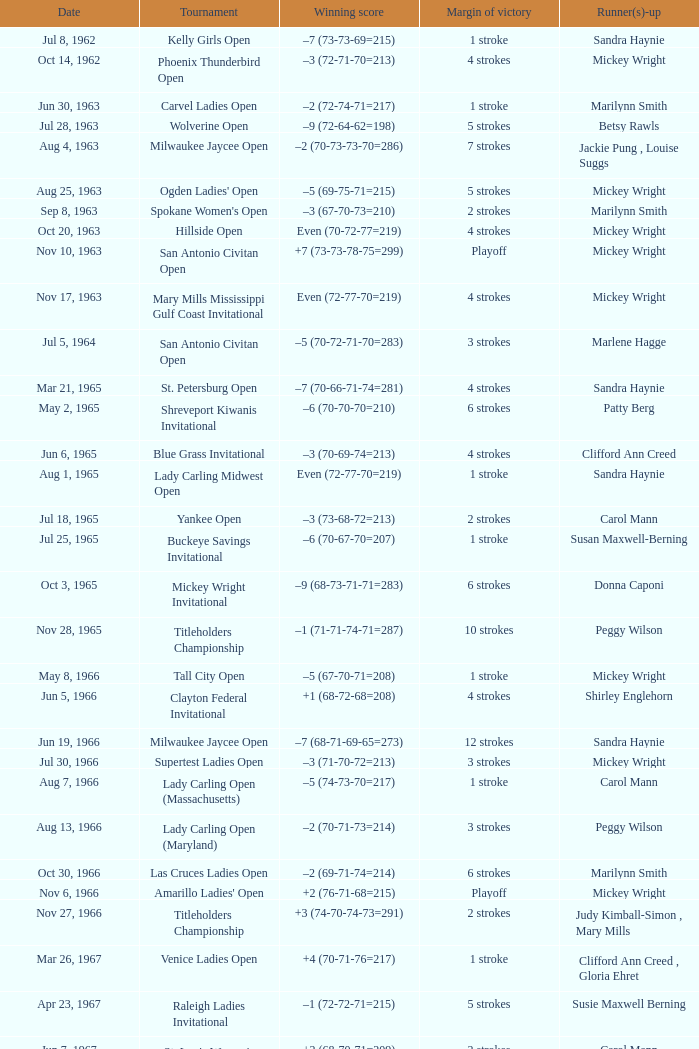What was the margin of victory on Apr 23, 1967? 5 strokes. 